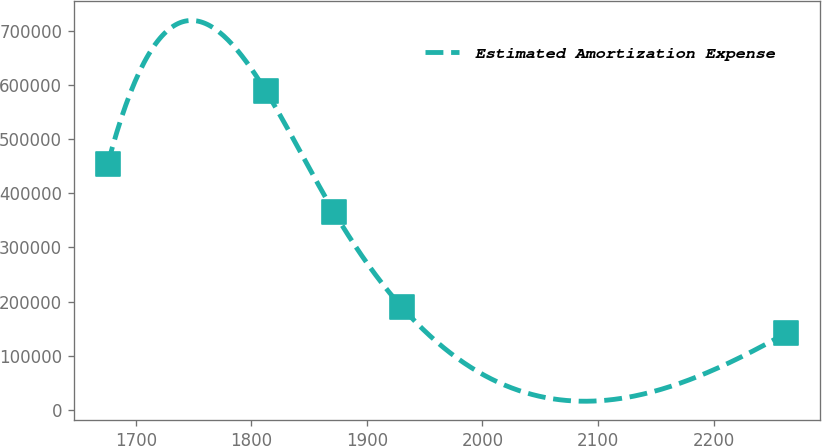<chart> <loc_0><loc_0><loc_500><loc_500><line_chart><ecel><fcel>Estimated Amortization Expense<nl><fcel>1675.65<fcel>453967<nl><fcel>1812.48<fcel>589104<nl><fcel>1871.23<fcel>366405<nl><fcel>1929.98<fcel>190050<nl><fcel>2263.11<fcel>141873<nl></chart> 